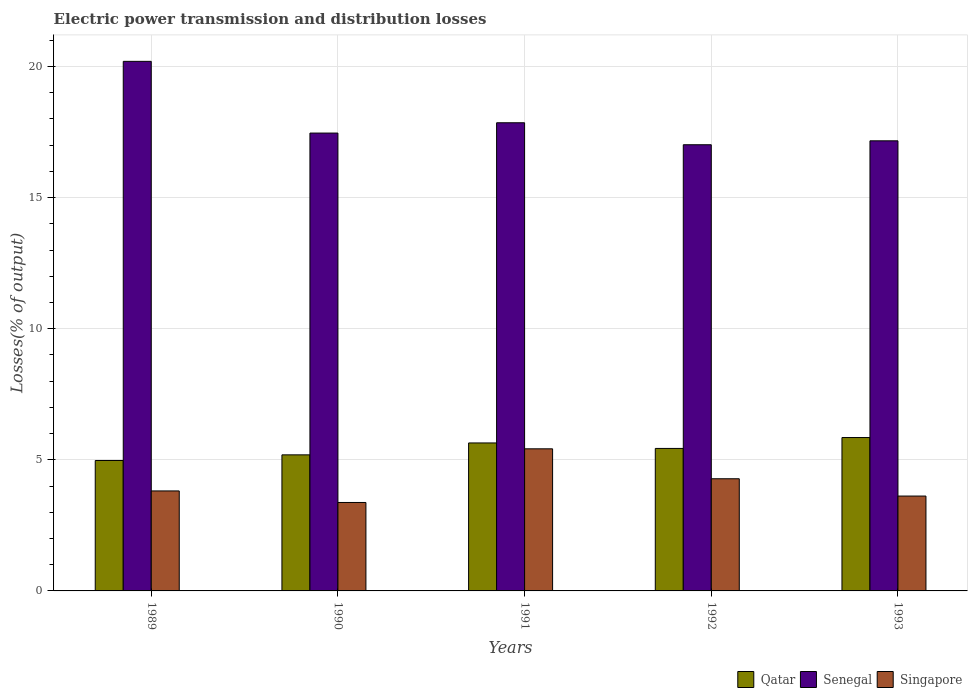How many groups of bars are there?
Make the answer very short. 5. Are the number of bars per tick equal to the number of legend labels?
Provide a short and direct response. Yes. How many bars are there on the 5th tick from the left?
Provide a succinct answer. 3. How many bars are there on the 4th tick from the right?
Your answer should be very brief. 3. What is the label of the 2nd group of bars from the left?
Make the answer very short. 1990. In how many cases, is the number of bars for a given year not equal to the number of legend labels?
Give a very brief answer. 0. What is the electric power transmission and distribution losses in Senegal in 1991?
Your response must be concise. 17.85. Across all years, what is the maximum electric power transmission and distribution losses in Qatar?
Your answer should be very brief. 5.85. Across all years, what is the minimum electric power transmission and distribution losses in Singapore?
Offer a terse response. 3.37. In which year was the electric power transmission and distribution losses in Singapore maximum?
Your answer should be very brief. 1991. What is the total electric power transmission and distribution losses in Singapore in the graph?
Provide a succinct answer. 20.5. What is the difference between the electric power transmission and distribution losses in Singapore in 1991 and that in 1993?
Give a very brief answer. 1.8. What is the difference between the electric power transmission and distribution losses in Singapore in 1992 and the electric power transmission and distribution losses in Qatar in 1989?
Provide a succinct answer. -0.7. What is the average electric power transmission and distribution losses in Singapore per year?
Give a very brief answer. 4.1. In the year 1993, what is the difference between the electric power transmission and distribution losses in Singapore and electric power transmission and distribution losses in Senegal?
Provide a short and direct response. -13.55. In how many years, is the electric power transmission and distribution losses in Senegal greater than 14 %?
Your response must be concise. 5. What is the ratio of the electric power transmission and distribution losses in Qatar in 1989 to that in 1993?
Provide a succinct answer. 0.85. Is the difference between the electric power transmission and distribution losses in Singapore in 1989 and 1992 greater than the difference between the electric power transmission and distribution losses in Senegal in 1989 and 1992?
Keep it short and to the point. No. What is the difference between the highest and the second highest electric power transmission and distribution losses in Qatar?
Provide a short and direct response. 0.21. What is the difference between the highest and the lowest electric power transmission and distribution losses in Singapore?
Offer a terse response. 2.05. In how many years, is the electric power transmission and distribution losses in Singapore greater than the average electric power transmission and distribution losses in Singapore taken over all years?
Your response must be concise. 2. What does the 2nd bar from the left in 1993 represents?
Make the answer very short. Senegal. What does the 2nd bar from the right in 1991 represents?
Your answer should be very brief. Senegal. Is it the case that in every year, the sum of the electric power transmission and distribution losses in Senegal and electric power transmission and distribution losses in Qatar is greater than the electric power transmission and distribution losses in Singapore?
Offer a very short reply. Yes. How many bars are there?
Offer a terse response. 15. Are all the bars in the graph horizontal?
Ensure brevity in your answer.  No. How many years are there in the graph?
Give a very brief answer. 5. Are the values on the major ticks of Y-axis written in scientific E-notation?
Ensure brevity in your answer.  No. Where does the legend appear in the graph?
Make the answer very short. Bottom right. How many legend labels are there?
Your response must be concise. 3. What is the title of the graph?
Keep it short and to the point. Electric power transmission and distribution losses. Does "Europe(developing only)" appear as one of the legend labels in the graph?
Your answer should be very brief. No. What is the label or title of the Y-axis?
Your answer should be compact. Losses(% of output). What is the Losses(% of output) of Qatar in 1989?
Your answer should be compact. 4.97. What is the Losses(% of output) in Senegal in 1989?
Your answer should be compact. 20.2. What is the Losses(% of output) in Singapore in 1989?
Give a very brief answer. 3.81. What is the Losses(% of output) in Qatar in 1990?
Ensure brevity in your answer.  5.19. What is the Losses(% of output) in Senegal in 1990?
Give a very brief answer. 17.46. What is the Losses(% of output) in Singapore in 1990?
Offer a very short reply. 3.37. What is the Losses(% of output) of Qatar in 1991?
Your answer should be very brief. 5.64. What is the Losses(% of output) of Senegal in 1991?
Offer a terse response. 17.85. What is the Losses(% of output) of Singapore in 1991?
Keep it short and to the point. 5.42. What is the Losses(% of output) in Qatar in 1992?
Your response must be concise. 5.43. What is the Losses(% of output) in Senegal in 1992?
Offer a very short reply. 17.02. What is the Losses(% of output) in Singapore in 1992?
Provide a short and direct response. 4.28. What is the Losses(% of output) in Qatar in 1993?
Your answer should be very brief. 5.85. What is the Losses(% of output) of Senegal in 1993?
Provide a short and direct response. 17.16. What is the Losses(% of output) in Singapore in 1993?
Ensure brevity in your answer.  3.62. Across all years, what is the maximum Losses(% of output) in Qatar?
Give a very brief answer. 5.85. Across all years, what is the maximum Losses(% of output) of Senegal?
Your response must be concise. 20.2. Across all years, what is the maximum Losses(% of output) in Singapore?
Offer a very short reply. 5.42. Across all years, what is the minimum Losses(% of output) in Qatar?
Give a very brief answer. 4.97. Across all years, what is the minimum Losses(% of output) in Senegal?
Ensure brevity in your answer.  17.02. Across all years, what is the minimum Losses(% of output) of Singapore?
Ensure brevity in your answer.  3.37. What is the total Losses(% of output) in Qatar in the graph?
Ensure brevity in your answer.  27.09. What is the total Losses(% of output) of Senegal in the graph?
Your answer should be compact. 89.69. What is the total Losses(% of output) in Singapore in the graph?
Offer a very short reply. 20.5. What is the difference between the Losses(% of output) in Qatar in 1989 and that in 1990?
Your answer should be very brief. -0.21. What is the difference between the Losses(% of output) in Senegal in 1989 and that in 1990?
Offer a terse response. 2.74. What is the difference between the Losses(% of output) in Singapore in 1989 and that in 1990?
Provide a succinct answer. 0.44. What is the difference between the Losses(% of output) in Qatar in 1989 and that in 1991?
Keep it short and to the point. -0.67. What is the difference between the Losses(% of output) of Senegal in 1989 and that in 1991?
Your answer should be very brief. 2.34. What is the difference between the Losses(% of output) of Singapore in 1989 and that in 1991?
Offer a very short reply. -1.61. What is the difference between the Losses(% of output) of Qatar in 1989 and that in 1992?
Ensure brevity in your answer.  -0.46. What is the difference between the Losses(% of output) in Senegal in 1989 and that in 1992?
Provide a short and direct response. 3.18. What is the difference between the Losses(% of output) of Singapore in 1989 and that in 1992?
Make the answer very short. -0.46. What is the difference between the Losses(% of output) of Qatar in 1989 and that in 1993?
Offer a very short reply. -0.88. What is the difference between the Losses(% of output) in Senegal in 1989 and that in 1993?
Offer a very short reply. 3.03. What is the difference between the Losses(% of output) in Singapore in 1989 and that in 1993?
Offer a terse response. 0.2. What is the difference between the Losses(% of output) of Qatar in 1990 and that in 1991?
Provide a short and direct response. -0.45. What is the difference between the Losses(% of output) of Senegal in 1990 and that in 1991?
Your answer should be compact. -0.39. What is the difference between the Losses(% of output) in Singapore in 1990 and that in 1991?
Provide a short and direct response. -2.05. What is the difference between the Losses(% of output) of Qatar in 1990 and that in 1992?
Ensure brevity in your answer.  -0.24. What is the difference between the Losses(% of output) of Senegal in 1990 and that in 1992?
Provide a succinct answer. 0.45. What is the difference between the Losses(% of output) of Singapore in 1990 and that in 1992?
Your answer should be very brief. -0.9. What is the difference between the Losses(% of output) of Qatar in 1990 and that in 1993?
Your answer should be very brief. -0.66. What is the difference between the Losses(% of output) in Senegal in 1990 and that in 1993?
Your answer should be compact. 0.3. What is the difference between the Losses(% of output) of Singapore in 1990 and that in 1993?
Provide a short and direct response. -0.24. What is the difference between the Losses(% of output) in Qatar in 1991 and that in 1992?
Provide a succinct answer. 0.21. What is the difference between the Losses(% of output) in Senegal in 1991 and that in 1992?
Your response must be concise. 0.84. What is the difference between the Losses(% of output) in Singapore in 1991 and that in 1992?
Your answer should be compact. 1.14. What is the difference between the Losses(% of output) in Qatar in 1991 and that in 1993?
Ensure brevity in your answer.  -0.21. What is the difference between the Losses(% of output) of Senegal in 1991 and that in 1993?
Your answer should be very brief. 0.69. What is the difference between the Losses(% of output) of Singapore in 1991 and that in 1993?
Your answer should be very brief. 1.8. What is the difference between the Losses(% of output) in Qatar in 1992 and that in 1993?
Ensure brevity in your answer.  -0.42. What is the difference between the Losses(% of output) in Senegal in 1992 and that in 1993?
Offer a terse response. -0.15. What is the difference between the Losses(% of output) in Singapore in 1992 and that in 1993?
Ensure brevity in your answer.  0.66. What is the difference between the Losses(% of output) of Qatar in 1989 and the Losses(% of output) of Senegal in 1990?
Keep it short and to the point. -12.49. What is the difference between the Losses(% of output) in Qatar in 1989 and the Losses(% of output) in Singapore in 1990?
Provide a short and direct response. 1.6. What is the difference between the Losses(% of output) in Senegal in 1989 and the Losses(% of output) in Singapore in 1990?
Your answer should be very brief. 16.82. What is the difference between the Losses(% of output) of Qatar in 1989 and the Losses(% of output) of Senegal in 1991?
Offer a very short reply. -12.88. What is the difference between the Losses(% of output) in Qatar in 1989 and the Losses(% of output) in Singapore in 1991?
Offer a very short reply. -0.45. What is the difference between the Losses(% of output) of Senegal in 1989 and the Losses(% of output) of Singapore in 1991?
Make the answer very short. 14.78. What is the difference between the Losses(% of output) of Qatar in 1989 and the Losses(% of output) of Senegal in 1992?
Make the answer very short. -12.04. What is the difference between the Losses(% of output) in Qatar in 1989 and the Losses(% of output) in Singapore in 1992?
Provide a succinct answer. 0.7. What is the difference between the Losses(% of output) in Senegal in 1989 and the Losses(% of output) in Singapore in 1992?
Make the answer very short. 15.92. What is the difference between the Losses(% of output) of Qatar in 1989 and the Losses(% of output) of Senegal in 1993?
Your answer should be compact. -12.19. What is the difference between the Losses(% of output) in Qatar in 1989 and the Losses(% of output) in Singapore in 1993?
Offer a terse response. 1.36. What is the difference between the Losses(% of output) of Senegal in 1989 and the Losses(% of output) of Singapore in 1993?
Give a very brief answer. 16.58. What is the difference between the Losses(% of output) of Qatar in 1990 and the Losses(% of output) of Senegal in 1991?
Keep it short and to the point. -12.66. What is the difference between the Losses(% of output) of Qatar in 1990 and the Losses(% of output) of Singapore in 1991?
Ensure brevity in your answer.  -0.23. What is the difference between the Losses(% of output) in Senegal in 1990 and the Losses(% of output) in Singapore in 1991?
Provide a succinct answer. 12.04. What is the difference between the Losses(% of output) in Qatar in 1990 and the Losses(% of output) in Senegal in 1992?
Provide a succinct answer. -11.83. What is the difference between the Losses(% of output) in Qatar in 1990 and the Losses(% of output) in Singapore in 1992?
Give a very brief answer. 0.91. What is the difference between the Losses(% of output) of Senegal in 1990 and the Losses(% of output) of Singapore in 1992?
Provide a short and direct response. 13.18. What is the difference between the Losses(% of output) in Qatar in 1990 and the Losses(% of output) in Senegal in 1993?
Offer a very short reply. -11.98. What is the difference between the Losses(% of output) of Qatar in 1990 and the Losses(% of output) of Singapore in 1993?
Your answer should be very brief. 1.57. What is the difference between the Losses(% of output) of Senegal in 1990 and the Losses(% of output) of Singapore in 1993?
Keep it short and to the point. 13.84. What is the difference between the Losses(% of output) in Qatar in 1991 and the Losses(% of output) in Senegal in 1992?
Provide a short and direct response. -11.37. What is the difference between the Losses(% of output) of Qatar in 1991 and the Losses(% of output) of Singapore in 1992?
Give a very brief answer. 1.37. What is the difference between the Losses(% of output) in Senegal in 1991 and the Losses(% of output) in Singapore in 1992?
Keep it short and to the point. 13.58. What is the difference between the Losses(% of output) in Qatar in 1991 and the Losses(% of output) in Senegal in 1993?
Provide a succinct answer. -11.52. What is the difference between the Losses(% of output) in Qatar in 1991 and the Losses(% of output) in Singapore in 1993?
Your answer should be very brief. 2.03. What is the difference between the Losses(% of output) of Senegal in 1991 and the Losses(% of output) of Singapore in 1993?
Make the answer very short. 14.24. What is the difference between the Losses(% of output) in Qatar in 1992 and the Losses(% of output) in Senegal in 1993?
Keep it short and to the point. -11.73. What is the difference between the Losses(% of output) in Qatar in 1992 and the Losses(% of output) in Singapore in 1993?
Keep it short and to the point. 1.82. What is the difference between the Losses(% of output) in Senegal in 1992 and the Losses(% of output) in Singapore in 1993?
Your answer should be very brief. 13.4. What is the average Losses(% of output) in Qatar per year?
Ensure brevity in your answer.  5.42. What is the average Losses(% of output) of Senegal per year?
Ensure brevity in your answer.  17.94. What is the average Losses(% of output) in Singapore per year?
Your answer should be compact. 4.1. In the year 1989, what is the difference between the Losses(% of output) of Qatar and Losses(% of output) of Senegal?
Keep it short and to the point. -15.22. In the year 1989, what is the difference between the Losses(% of output) of Qatar and Losses(% of output) of Singapore?
Ensure brevity in your answer.  1.16. In the year 1989, what is the difference between the Losses(% of output) of Senegal and Losses(% of output) of Singapore?
Your response must be concise. 16.38. In the year 1990, what is the difference between the Losses(% of output) in Qatar and Losses(% of output) in Senegal?
Offer a very short reply. -12.27. In the year 1990, what is the difference between the Losses(% of output) of Qatar and Losses(% of output) of Singapore?
Provide a short and direct response. 1.82. In the year 1990, what is the difference between the Losses(% of output) in Senegal and Losses(% of output) in Singapore?
Your answer should be very brief. 14.09. In the year 1991, what is the difference between the Losses(% of output) in Qatar and Losses(% of output) in Senegal?
Offer a very short reply. -12.21. In the year 1991, what is the difference between the Losses(% of output) in Qatar and Losses(% of output) in Singapore?
Your response must be concise. 0.22. In the year 1991, what is the difference between the Losses(% of output) in Senegal and Losses(% of output) in Singapore?
Your answer should be very brief. 12.43. In the year 1992, what is the difference between the Losses(% of output) of Qatar and Losses(% of output) of Senegal?
Your answer should be compact. -11.58. In the year 1992, what is the difference between the Losses(% of output) in Qatar and Losses(% of output) in Singapore?
Give a very brief answer. 1.16. In the year 1992, what is the difference between the Losses(% of output) of Senegal and Losses(% of output) of Singapore?
Your response must be concise. 12.74. In the year 1993, what is the difference between the Losses(% of output) in Qatar and Losses(% of output) in Senegal?
Keep it short and to the point. -11.32. In the year 1993, what is the difference between the Losses(% of output) in Qatar and Losses(% of output) in Singapore?
Offer a very short reply. 2.23. In the year 1993, what is the difference between the Losses(% of output) in Senegal and Losses(% of output) in Singapore?
Your answer should be compact. 13.55. What is the ratio of the Losses(% of output) of Qatar in 1989 to that in 1990?
Your answer should be compact. 0.96. What is the ratio of the Losses(% of output) in Senegal in 1989 to that in 1990?
Give a very brief answer. 1.16. What is the ratio of the Losses(% of output) in Singapore in 1989 to that in 1990?
Ensure brevity in your answer.  1.13. What is the ratio of the Losses(% of output) of Qatar in 1989 to that in 1991?
Offer a terse response. 0.88. What is the ratio of the Losses(% of output) of Senegal in 1989 to that in 1991?
Ensure brevity in your answer.  1.13. What is the ratio of the Losses(% of output) of Singapore in 1989 to that in 1991?
Make the answer very short. 0.7. What is the ratio of the Losses(% of output) in Qatar in 1989 to that in 1992?
Make the answer very short. 0.92. What is the ratio of the Losses(% of output) of Senegal in 1989 to that in 1992?
Offer a very short reply. 1.19. What is the ratio of the Losses(% of output) in Singapore in 1989 to that in 1992?
Make the answer very short. 0.89. What is the ratio of the Losses(% of output) in Qatar in 1989 to that in 1993?
Provide a succinct answer. 0.85. What is the ratio of the Losses(% of output) of Senegal in 1989 to that in 1993?
Make the answer very short. 1.18. What is the ratio of the Losses(% of output) in Singapore in 1989 to that in 1993?
Give a very brief answer. 1.05. What is the ratio of the Losses(% of output) in Qatar in 1990 to that in 1991?
Make the answer very short. 0.92. What is the ratio of the Losses(% of output) in Singapore in 1990 to that in 1991?
Give a very brief answer. 0.62. What is the ratio of the Losses(% of output) in Qatar in 1990 to that in 1992?
Provide a short and direct response. 0.95. What is the ratio of the Losses(% of output) in Senegal in 1990 to that in 1992?
Ensure brevity in your answer.  1.03. What is the ratio of the Losses(% of output) in Singapore in 1990 to that in 1992?
Make the answer very short. 0.79. What is the ratio of the Losses(% of output) of Qatar in 1990 to that in 1993?
Offer a very short reply. 0.89. What is the ratio of the Losses(% of output) in Senegal in 1990 to that in 1993?
Your response must be concise. 1.02. What is the ratio of the Losses(% of output) in Singapore in 1990 to that in 1993?
Your answer should be compact. 0.93. What is the ratio of the Losses(% of output) of Qatar in 1991 to that in 1992?
Keep it short and to the point. 1.04. What is the ratio of the Losses(% of output) in Senegal in 1991 to that in 1992?
Your response must be concise. 1.05. What is the ratio of the Losses(% of output) in Singapore in 1991 to that in 1992?
Offer a very short reply. 1.27. What is the ratio of the Losses(% of output) of Qatar in 1991 to that in 1993?
Your answer should be very brief. 0.96. What is the ratio of the Losses(% of output) of Senegal in 1991 to that in 1993?
Offer a terse response. 1.04. What is the ratio of the Losses(% of output) of Singapore in 1991 to that in 1993?
Provide a succinct answer. 1.5. What is the ratio of the Losses(% of output) of Qatar in 1992 to that in 1993?
Ensure brevity in your answer.  0.93. What is the ratio of the Losses(% of output) in Singapore in 1992 to that in 1993?
Your response must be concise. 1.18. What is the difference between the highest and the second highest Losses(% of output) in Qatar?
Keep it short and to the point. 0.21. What is the difference between the highest and the second highest Losses(% of output) of Senegal?
Ensure brevity in your answer.  2.34. What is the difference between the highest and the second highest Losses(% of output) in Singapore?
Offer a very short reply. 1.14. What is the difference between the highest and the lowest Losses(% of output) in Qatar?
Make the answer very short. 0.88. What is the difference between the highest and the lowest Losses(% of output) in Senegal?
Keep it short and to the point. 3.18. What is the difference between the highest and the lowest Losses(% of output) in Singapore?
Keep it short and to the point. 2.05. 